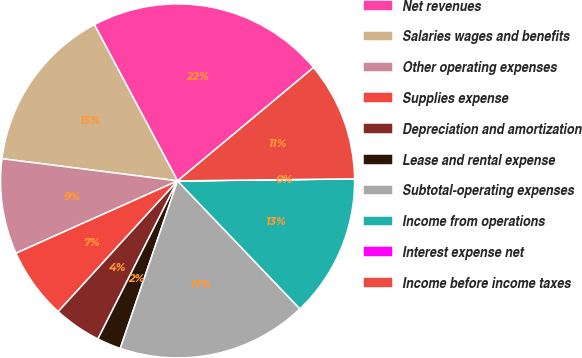<chart> <loc_0><loc_0><loc_500><loc_500><pie_chart><fcel>Net revenues<fcel>Salaries wages and benefits<fcel>Other operating expenses<fcel>Supplies expense<fcel>Depreciation and amortization<fcel>Lease and rental expense<fcel>Subtotal-operating expenses<fcel>Income from operations<fcel>Interest expense net<fcel>Income before income taxes<nl><fcel>21.73%<fcel>15.21%<fcel>8.7%<fcel>6.52%<fcel>4.35%<fcel>2.18%<fcel>17.39%<fcel>13.04%<fcel>0.01%<fcel>10.87%<nl></chart> 